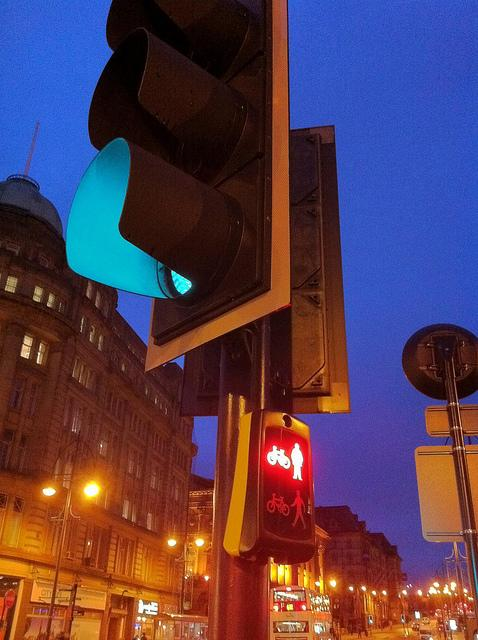What does the bottom red light prohibit?

Choices:
A) loitering
B) crossing
C) trading
D) racing crossing 